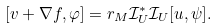Convert formula to latex. <formula><loc_0><loc_0><loc_500><loc_500>[ v + \nabla f , \varphi ] = r _ { M } \mathcal { I } ^ { \ast } _ { U } \mathcal { I } _ { U } [ u , \psi ] .</formula> 